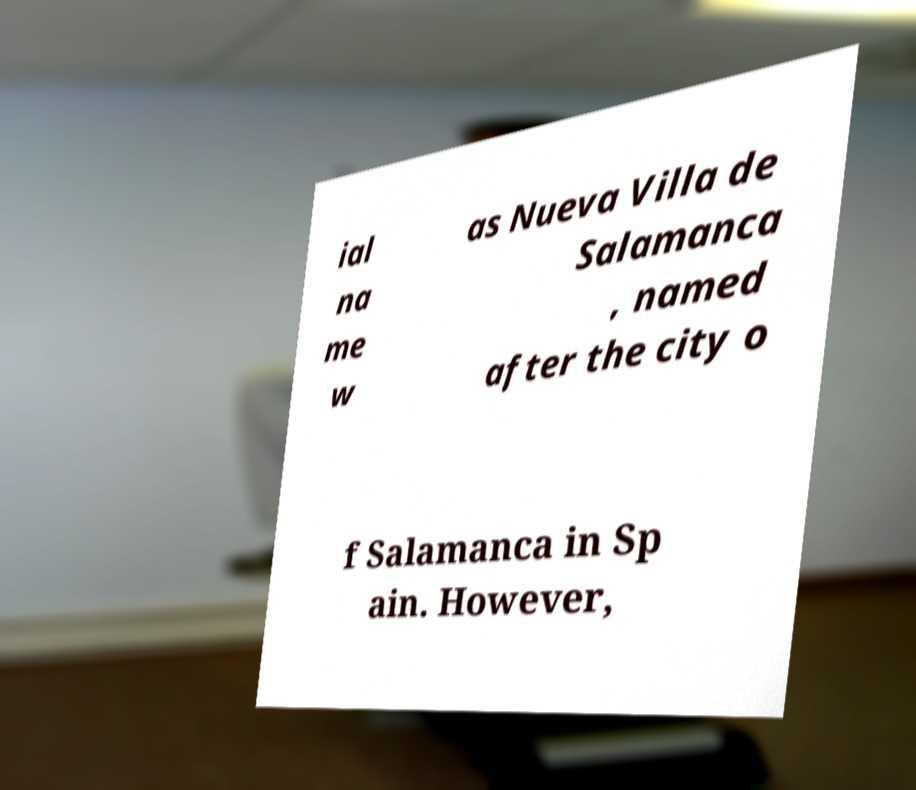Can you accurately transcribe the text from the provided image for me? ial na me w as Nueva Villa de Salamanca , named after the city o f Salamanca in Sp ain. However, 